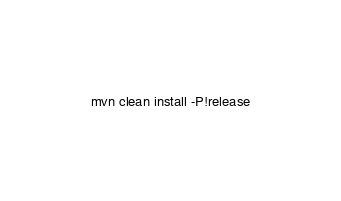<code> <loc_0><loc_0><loc_500><loc_500><_Bash_>mvn clean install -P!release
</code> 